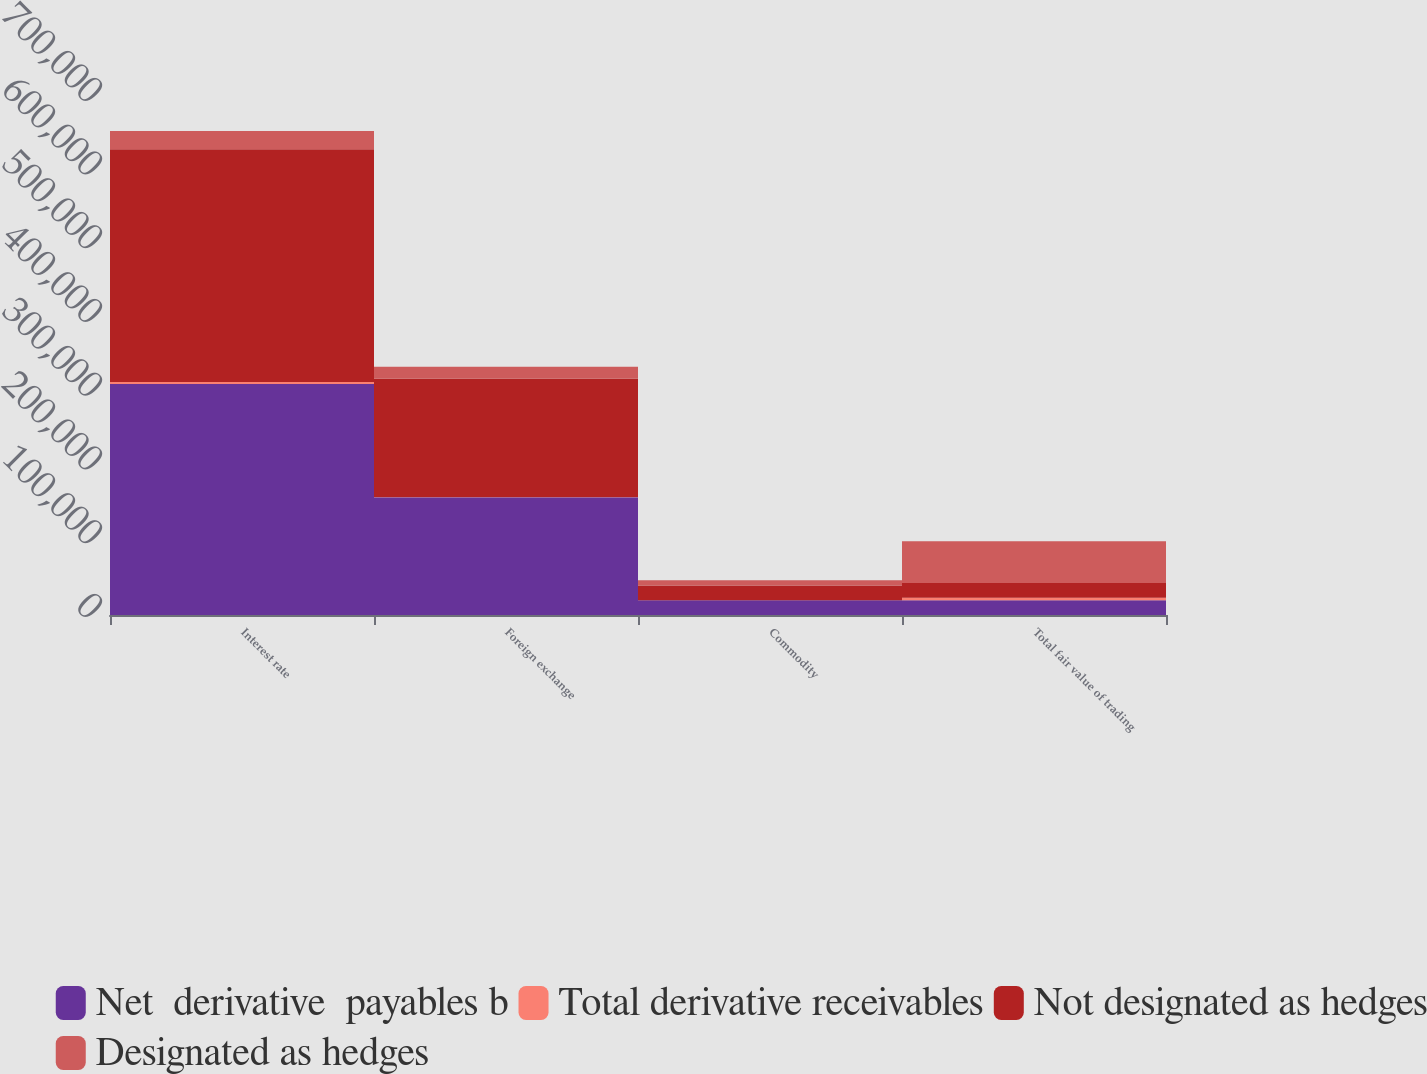<chart> <loc_0><loc_0><loc_500><loc_500><stacked_bar_chart><ecel><fcel>Interest rate<fcel>Foreign exchange<fcel>Commodity<fcel>Total fair value of trading<nl><fcel>Net  derivative  payables b<fcel>313276<fcel>159740<fcel>20066<fcel>20075.5<nl><fcel>Total derivative receivables<fcel>2716<fcel>491<fcel>19<fcel>3226<nl><fcel>Not designated as hedges<fcel>315992<fcel>160231<fcel>20085<fcel>20075.5<nl><fcel>Designated as hedges<fcel>24673<fcel>16151<fcel>6948<fcel>56523<nl></chart> 